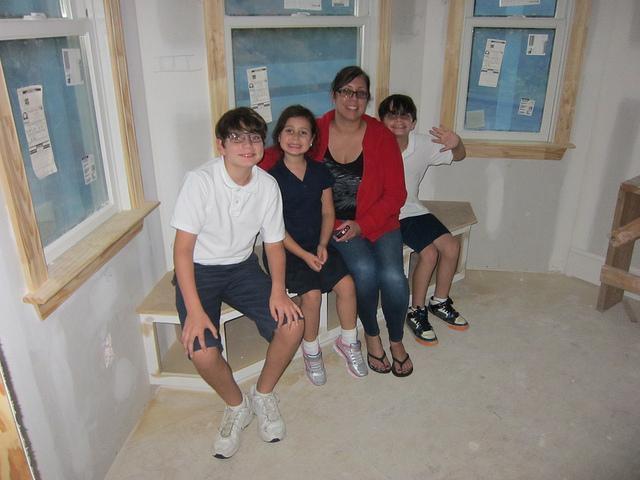How many people are there?
Give a very brief answer. 4. How many sheep are there?
Give a very brief answer. 0. 